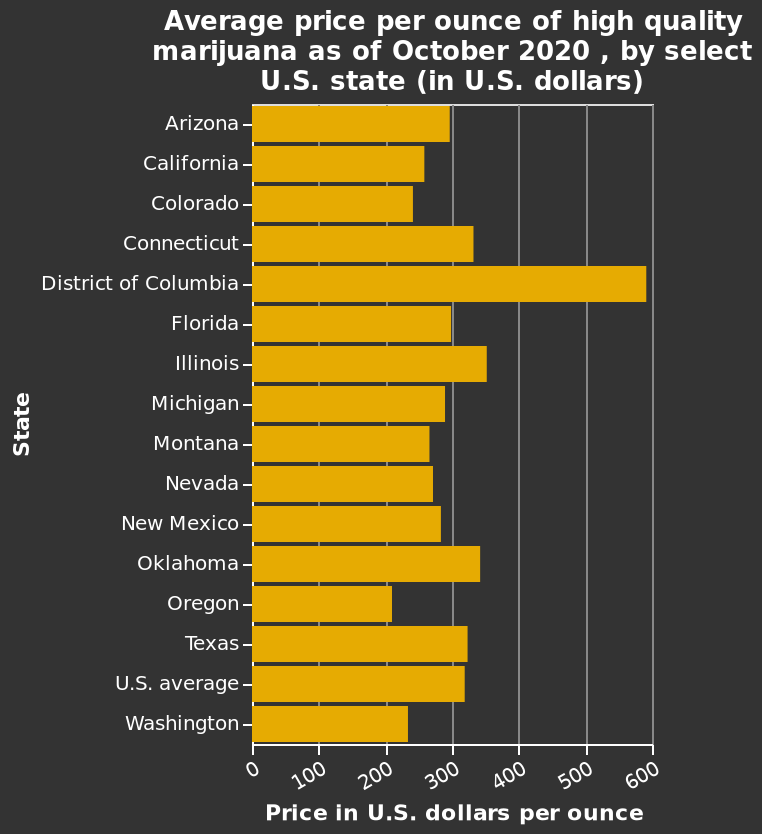<image>
What is the quality of the marijuana being measured in the bar chart? The bar chart represents the average price per ounce of high-quality marijuana. What does the bar chart depict? The bar chart depicts the average price per ounce of high-quality marijuana in select U.S. states as of October 2020. Does the line graph represent the above-average price per pound of low-quality marijuana? No.The bar chart represents the average price per ounce of high-quality marijuana. 